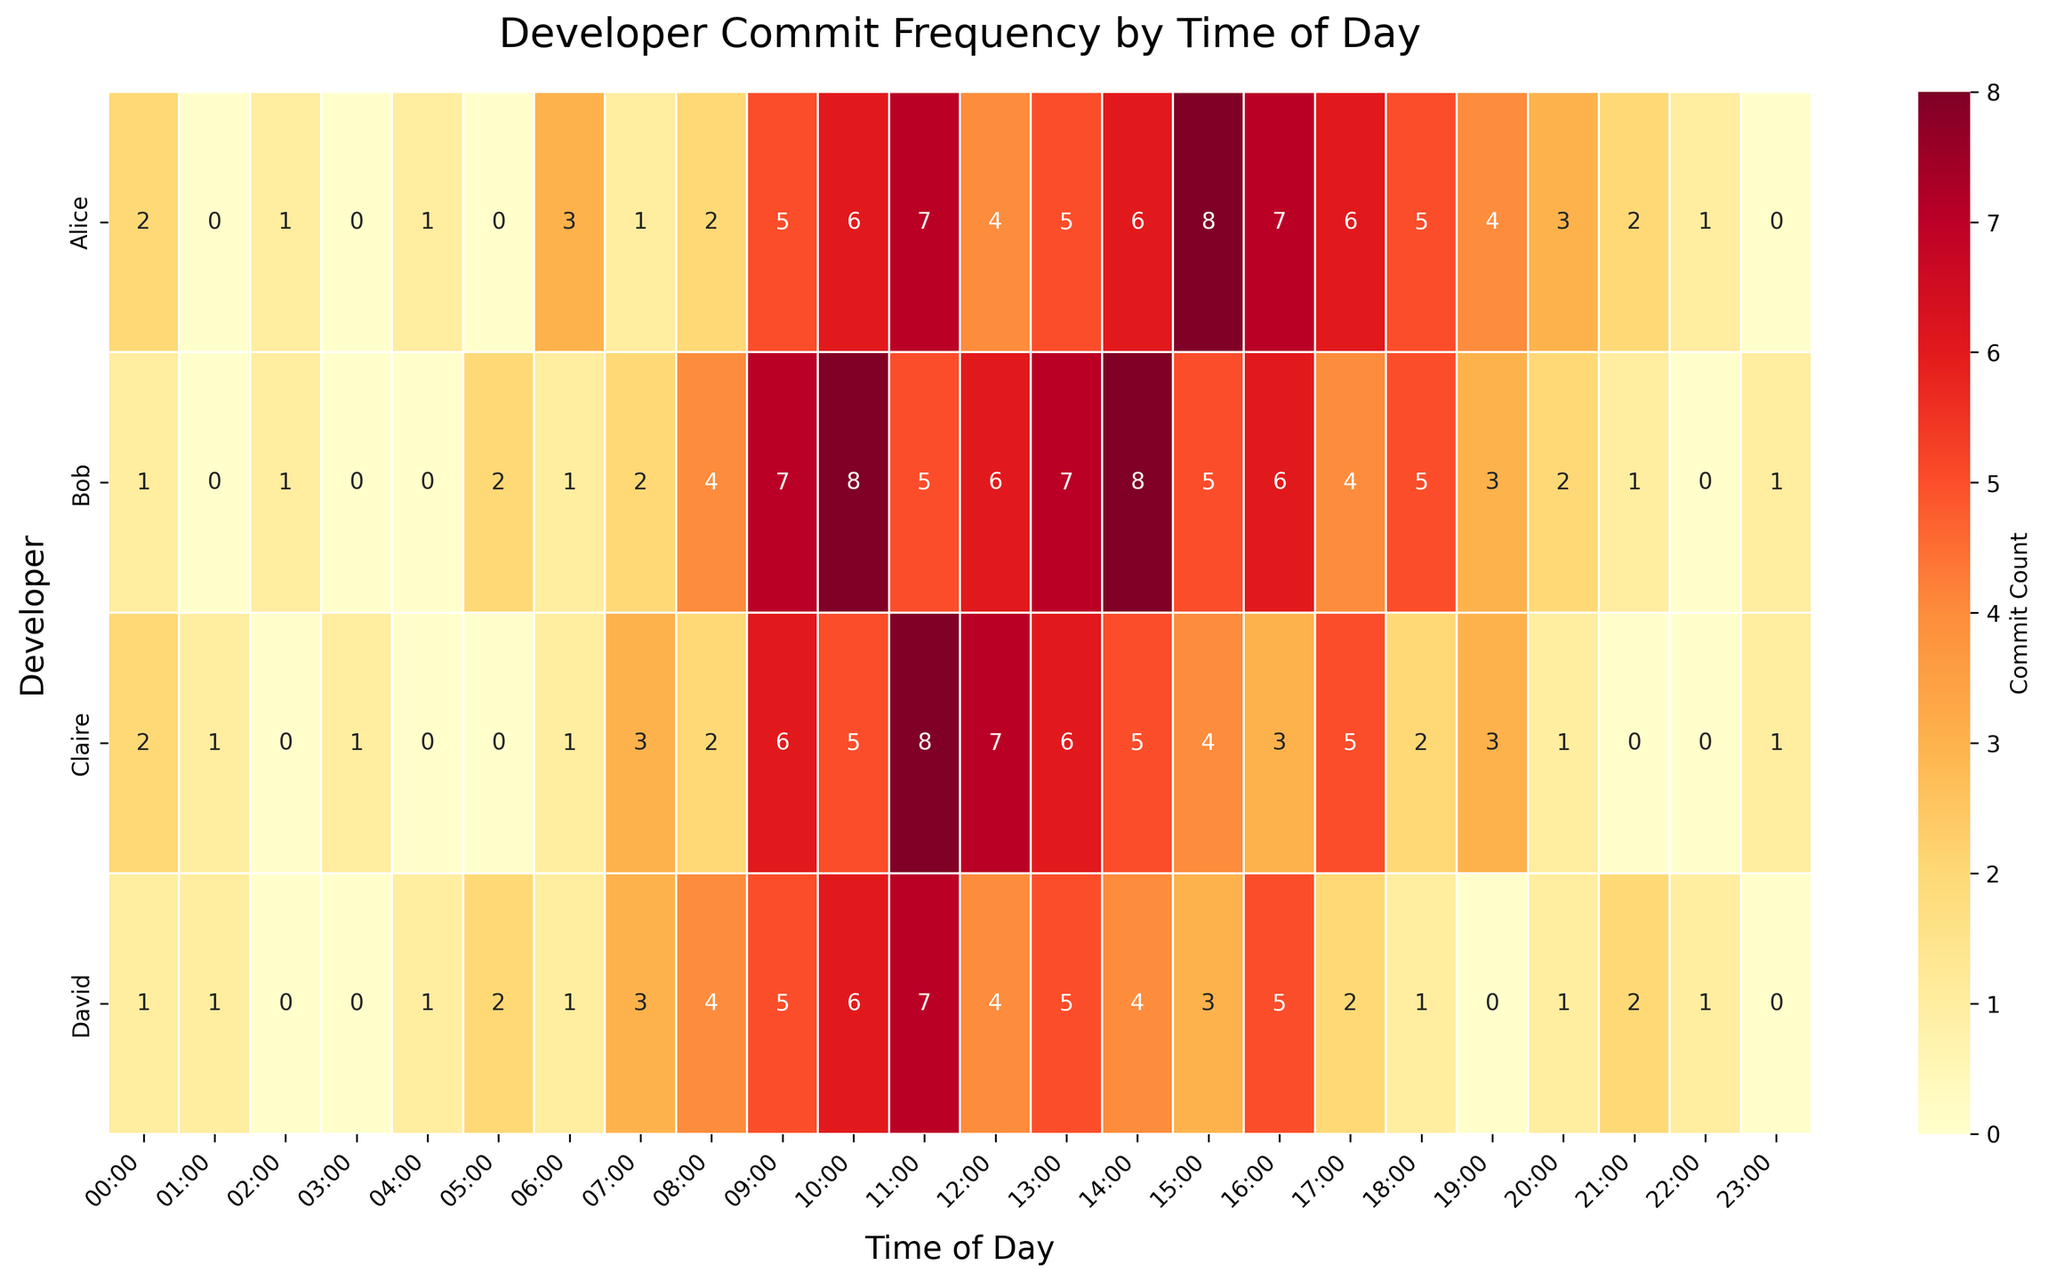Which time of day has the highest commit count for Alice? Look for the highest value in Alice's row, which is located under column "15:00" with a commit count of 8.
Answer: 15:00 What is the average commit count for Bob over the 24-hour period? Sum all the commit counts for Bob and divide by 24 (1+0+1+0+0+2+1+2+4+7+8+5+6+7+8+5+6+4+5+3+2+1+0+1 = 79, 79/24 ≈ 3.29).
Answer: 3.29 Who has the highest total commit count? Calculate the sum of commit counts for each developer. Alice (83), Bob (79), Claire (68), David (62). Alice has the highest total commit count at 83.
Answer: Alice Between 10:00 and 16:00, which developer shows the most consistent activity in terms of commit frequency? Calculate the standard deviation of commit counts between 10:00 and 16:00 for each developer. Alice (2.19), Bob (1.22), Claire (2.12), David (1.84). Bob has the lowest standard deviation and the most consistent activity.
Answer: Bob Who has the highest commit count at 11:00? Look for the highest value in the 11:00 column. Claire has the highest commit count of 8 at 11:00.
Answer: Claire What is the difference in the total number of commits between the most active and least active developers? Sum all commit counts for each developer. Alice (83), Bob (79), Claire (68), David (62). Difference between Alice and David is 83 - 62 = 21.
Answer: 21 What pattern can be observed in Claire's commit frequency throughout the day? Review Claire's row, noting peaks and troughs; high activity between 10:00 - 13:00, reduced activity afterward, and minimal in early and late hours. Possible natural working hours pattern.
Answer: Peaks late morning, declines in the evening Which time slot has the least variance in commit frequency across all developers? Calculate variance for each time slot. For example, 10:00 (Alice 6, Bob 8, Claire 5, David 6) variance = 1.25. Repeat for all time slots, identifying 02:00 has one of the lowest variances (~0.5).
Answer: 02:00 